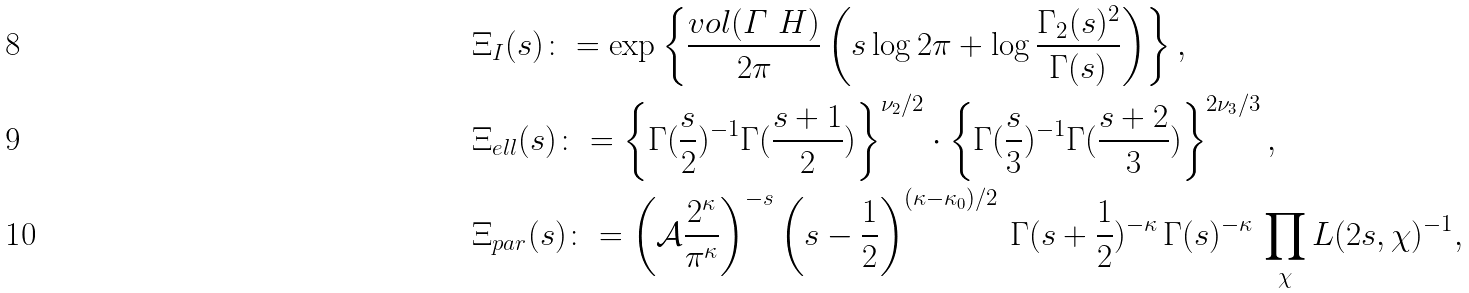Convert formula to latex. <formula><loc_0><loc_0><loc_500><loc_500>& \Xi _ { I } ( s ) \colon = \exp \left \{ \frac { v o l ( \varGamma \ H ) } { 2 \pi } \left ( s \log 2 \pi + \log \frac { \Gamma _ { 2 } ( s ) ^ { 2 } } { \Gamma ( s ) } \right ) \right \} , \\ & \Xi _ { e l l } ( s ) \colon = \left \{ \Gamma ( \frac { s } { 2 } ) ^ { - 1 } \Gamma ( \frac { s + 1 } { 2 } ) \right \} ^ { \nu _ { 2 } / 2 } \cdot \left \{ \Gamma ( \frac { s } { 3 } ) ^ { - 1 } \Gamma ( \frac { s + 2 } { 3 } ) \right \} ^ { 2 \nu _ { 3 } / 3 } , \\ & \Xi _ { p a r } ( s ) \colon = \left ( \mathcal { A } \frac { 2 ^ { \kappa } } { \pi ^ { \kappa } } \right ) ^ { - s } \left ( s - \frac { 1 } { 2 } \right ) ^ { ( \kappa - \kappa _ { 0 } ) / 2 } \, \Gamma ( s + \frac { 1 } { 2 } ) ^ { - \kappa } \, \Gamma ( s ) ^ { - \kappa } \, \prod _ { \chi } L ( 2 s , \chi ) ^ { - 1 } ,</formula> 